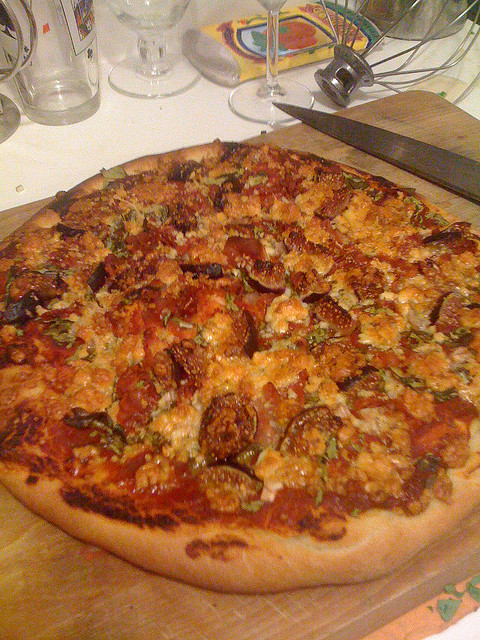<image>What is one clue that this is a fairly recent photo? There is no clear clue that tells us this is a recent photo. It possibly can be the pixel quality or the freshness of the pizza. What is one clue that this is a fairly recent photo? I don't know what is one clue that this is a fairly recent photo. It could be the pixel quality, color, or the presence of an advertisement. 